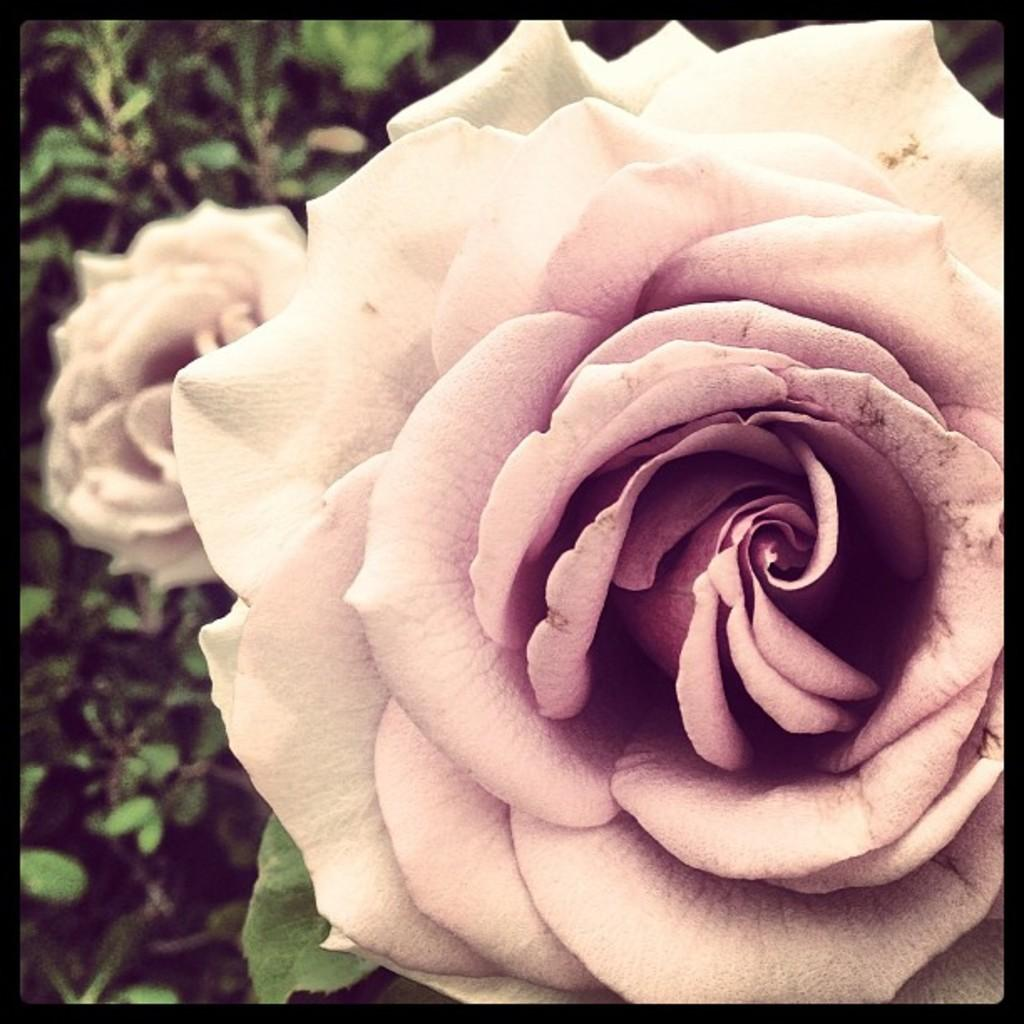What type of flowers can be seen in the image? There are pink flowers in the image. What else is present in the image besides the pink flowers? There are plants in the image. How many balls can be seen in the image? There are no balls present in the image. 